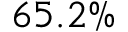<formula> <loc_0><loc_0><loc_500><loc_500>6 5 . 2 \%</formula> 